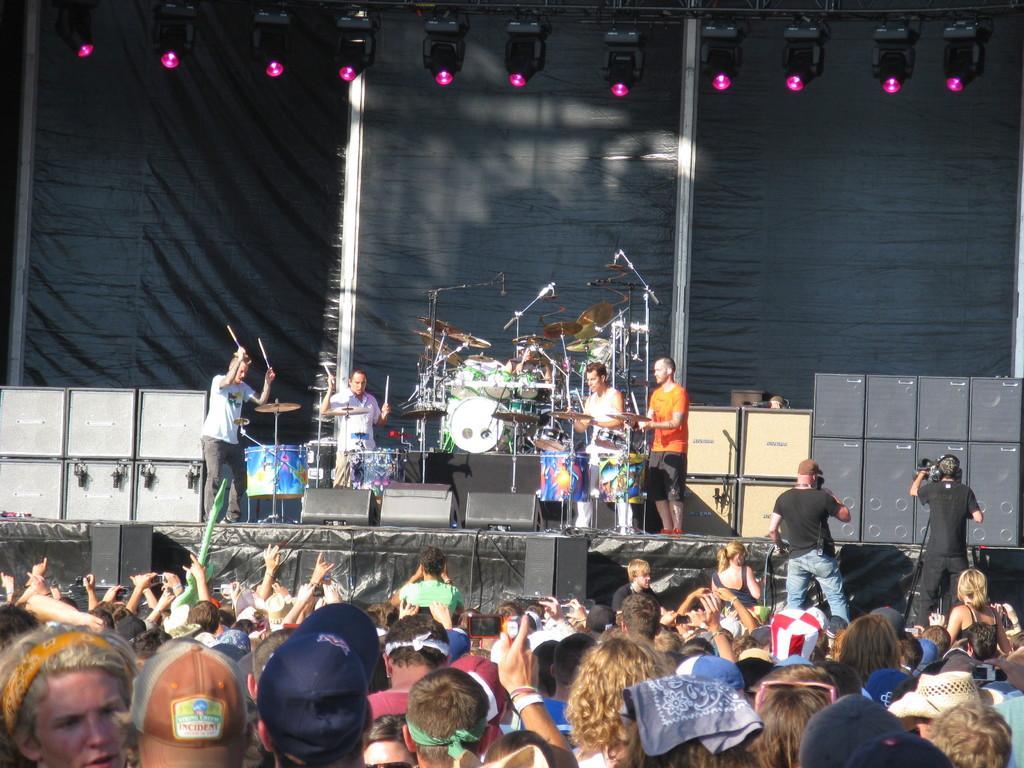Please provide a concise description of this image. In this image we can see a few people, among them some are playing musical instruments, in the background we can see some lights and speakers. 